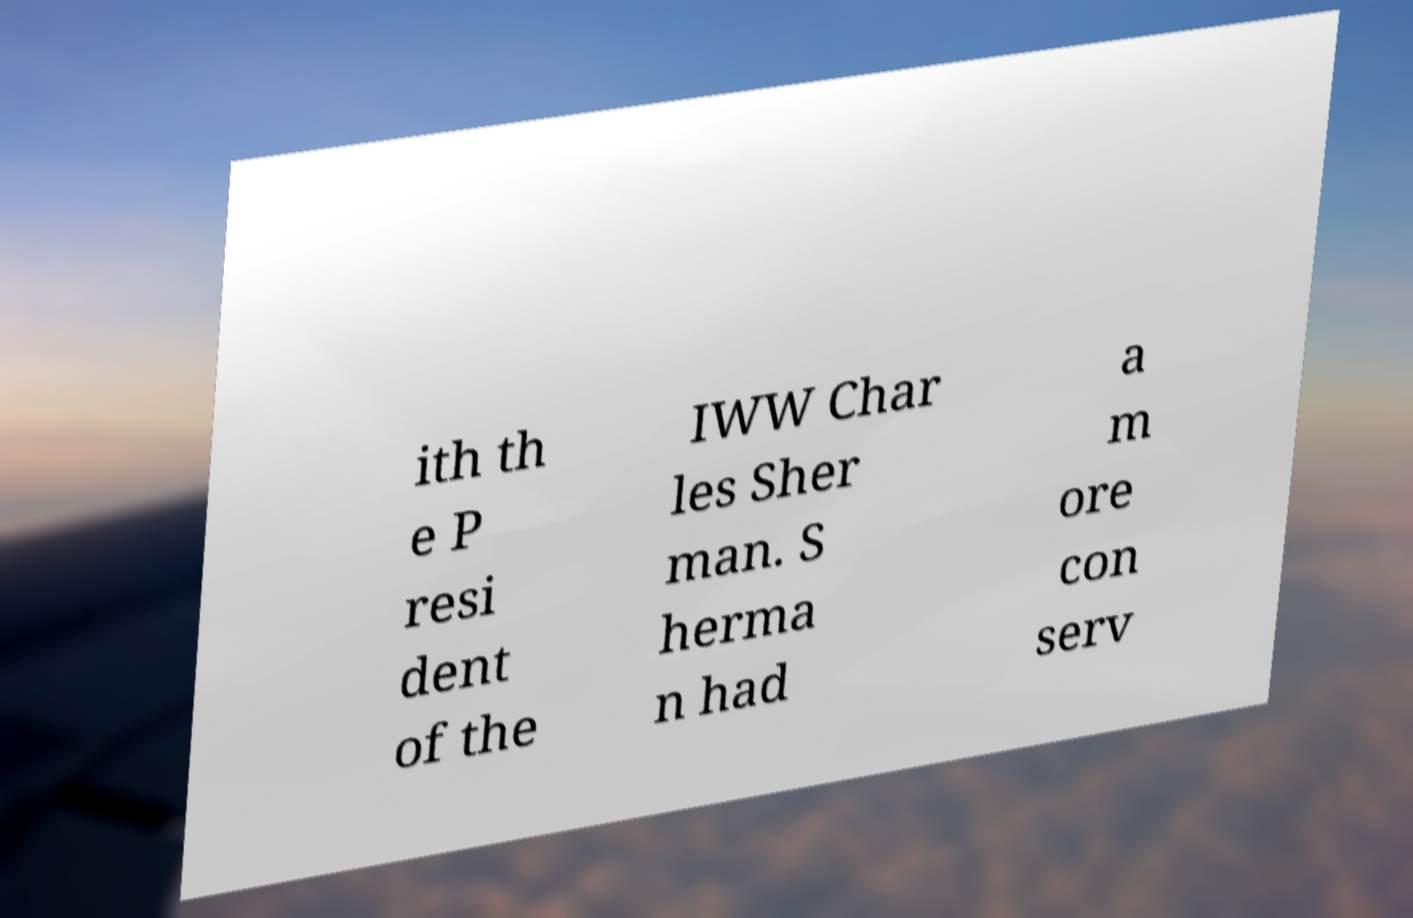What messages or text are displayed in this image? I need them in a readable, typed format. ith th e P resi dent of the IWW Char les Sher man. S herma n had a m ore con serv 